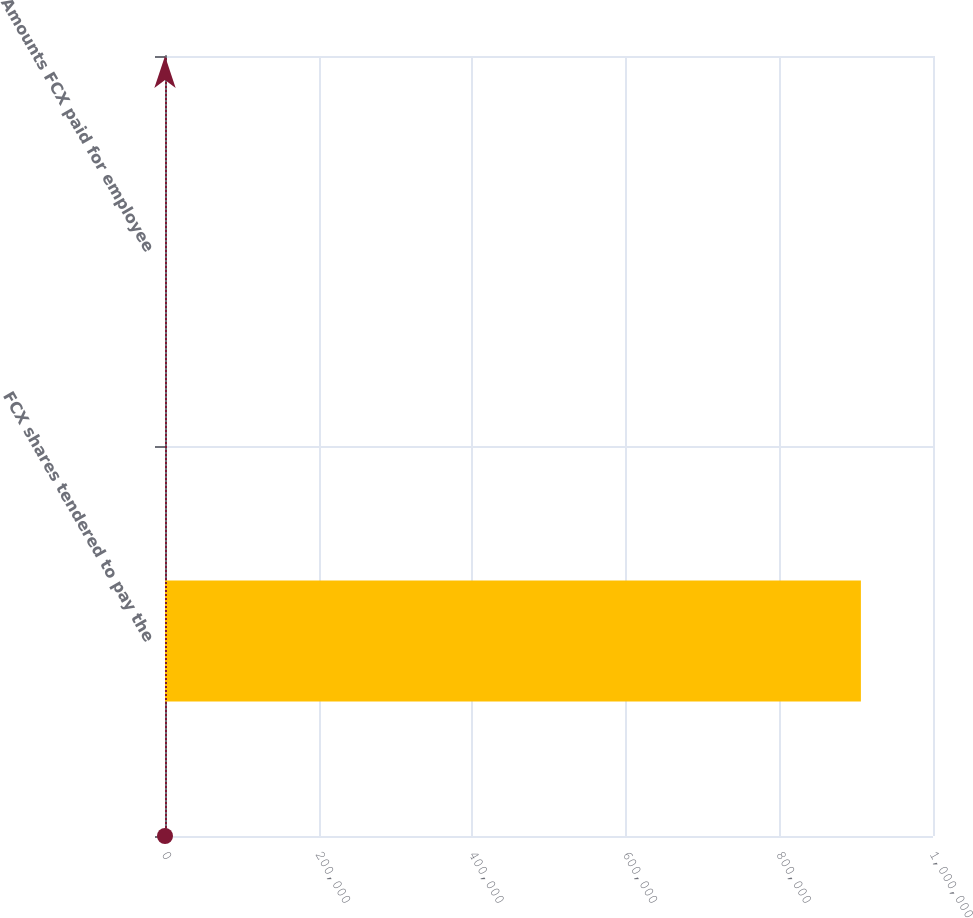Convert chart. <chart><loc_0><loc_0><loc_500><loc_500><bar_chart><fcel>FCX shares tendered to pay the<fcel>Amounts FCX paid for employee<nl><fcel>906120<fcel>6<nl></chart> 